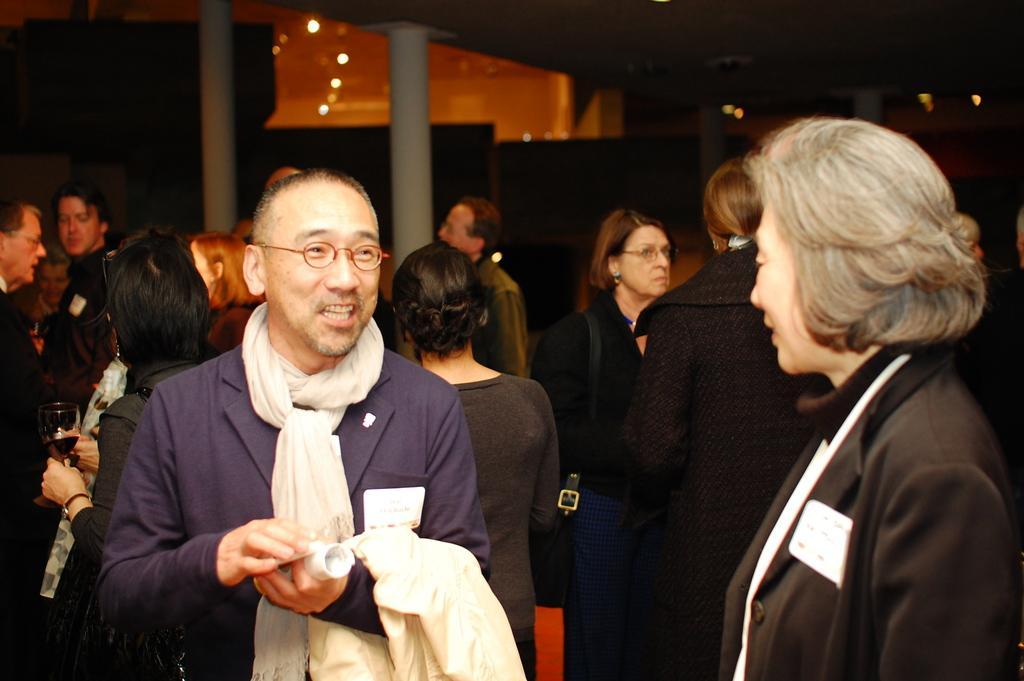Can you describe this image briefly? In this picture there are people, among them there's a man standing and smiling and holding cloth and objects. In the background of the image it is dark and we can see pillars and lights. 